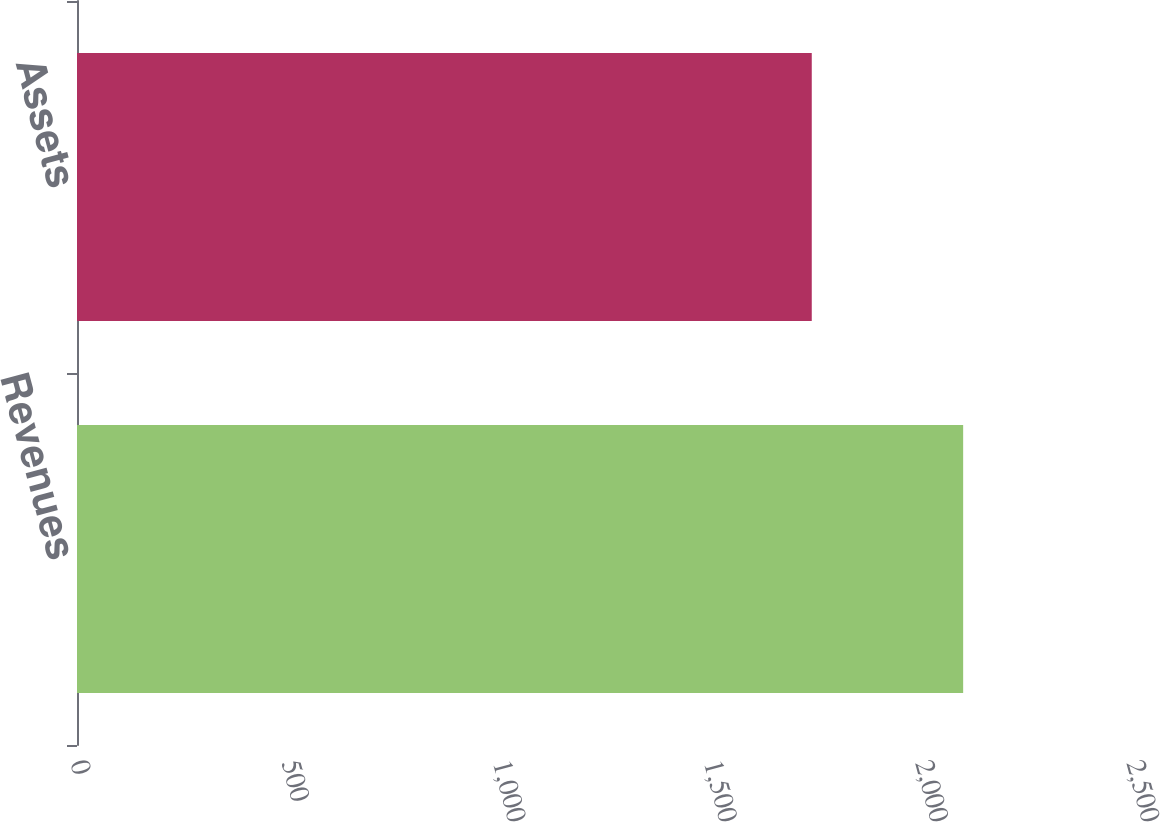Convert chart to OTSL. <chart><loc_0><loc_0><loc_500><loc_500><bar_chart><fcel>Revenues<fcel>Assets<nl><fcel>2097.9<fcel>1739.5<nl></chart> 